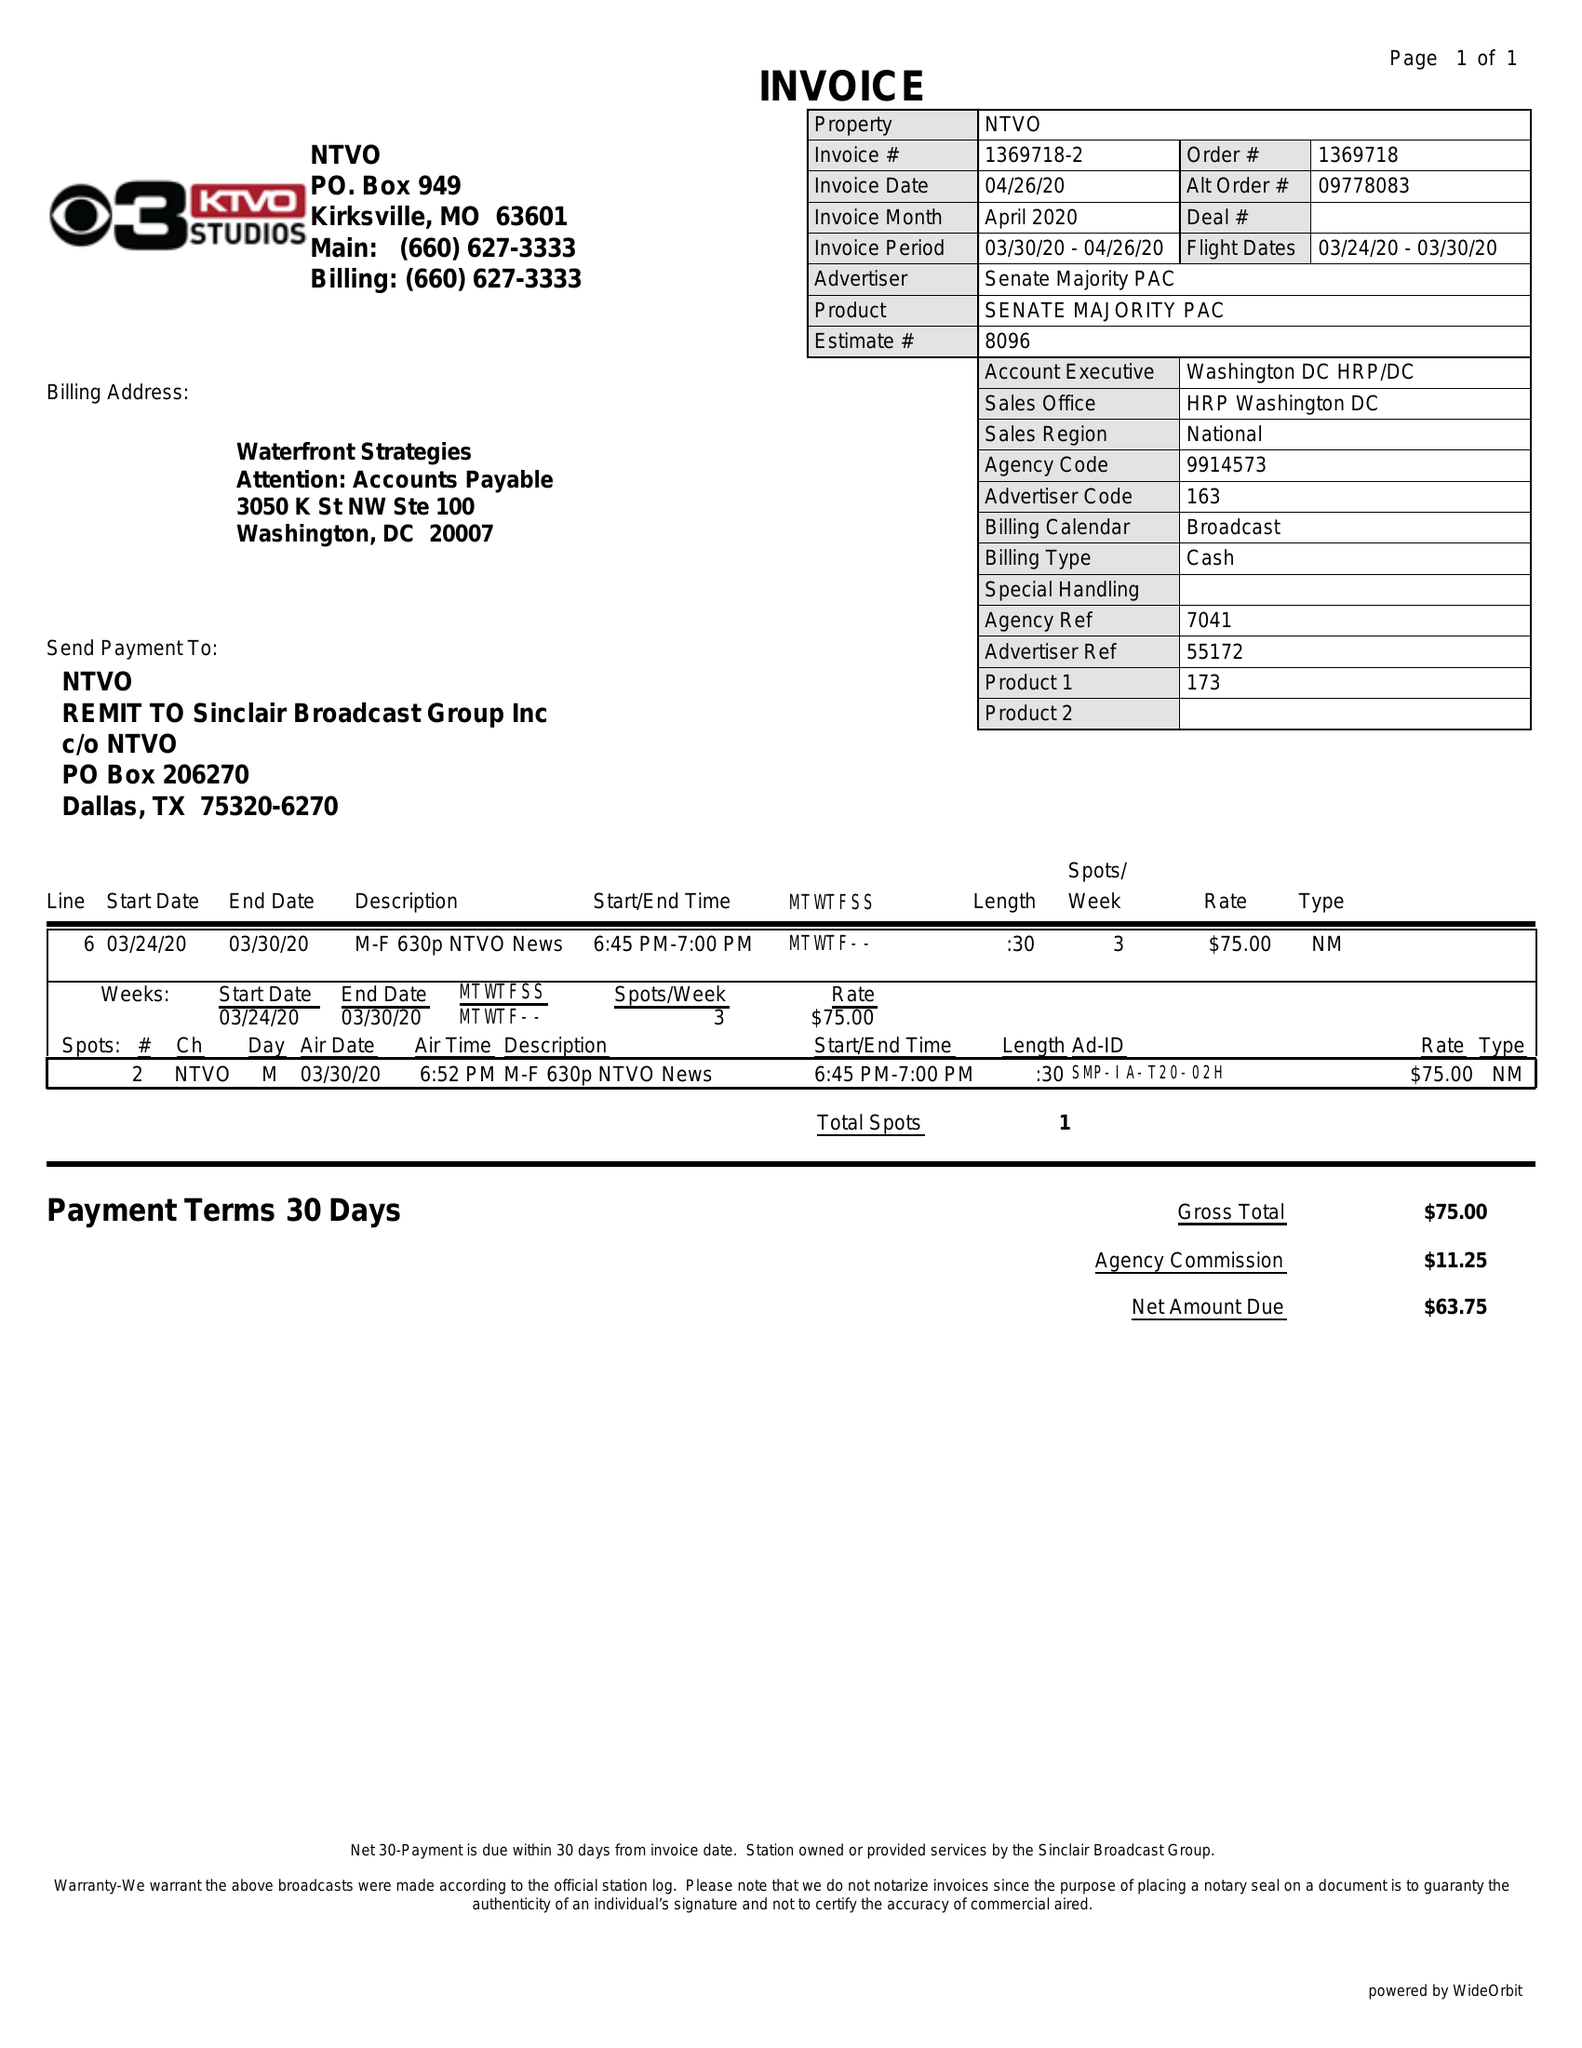What is the value for the flight_to?
Answer the question using a single word or phrase. 03/30/20 